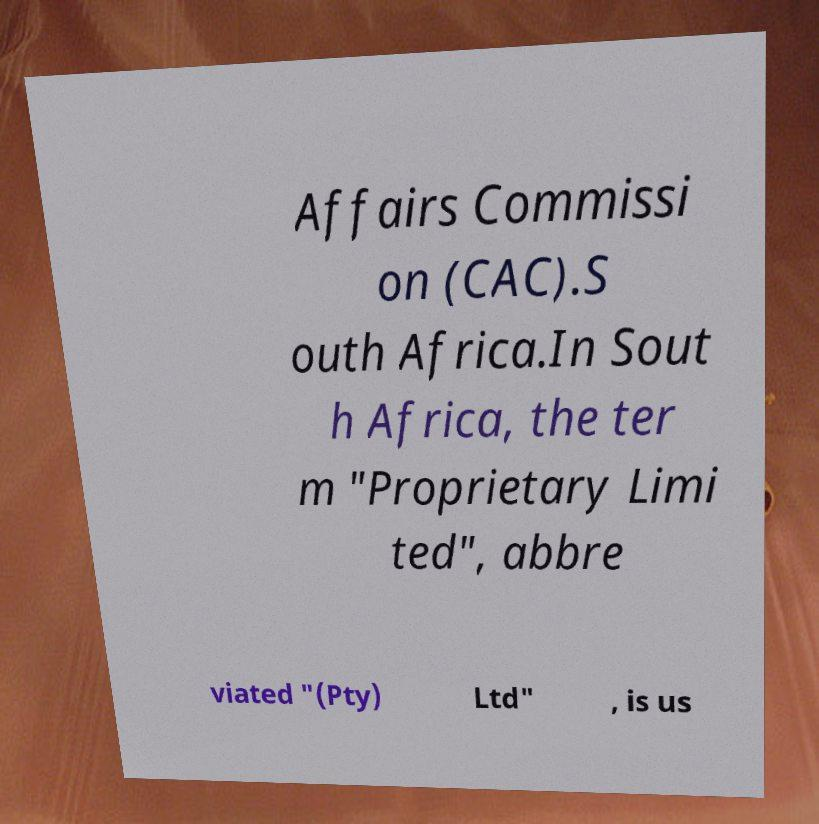Please read and relay the text visible in this image. What does it say? Affairs Commissi on (CAC).S outh Africa.In Sout h Africa, the ter m "Proprietary Limi ted", abbre viated "(Pty) Ltd" , is us 